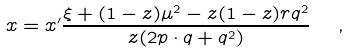<formula> <loc_0><loc_0><loc_500><loc_500>x = x ^ { \prime } \frac { \xi + ( 1 - z ) \mu ^ { 2 } - z ( 1 - z ) r q ^ { 2 } } { z ( 2 p \cdot q + q ^ { 2 } ) } \ \ ,</formula> 